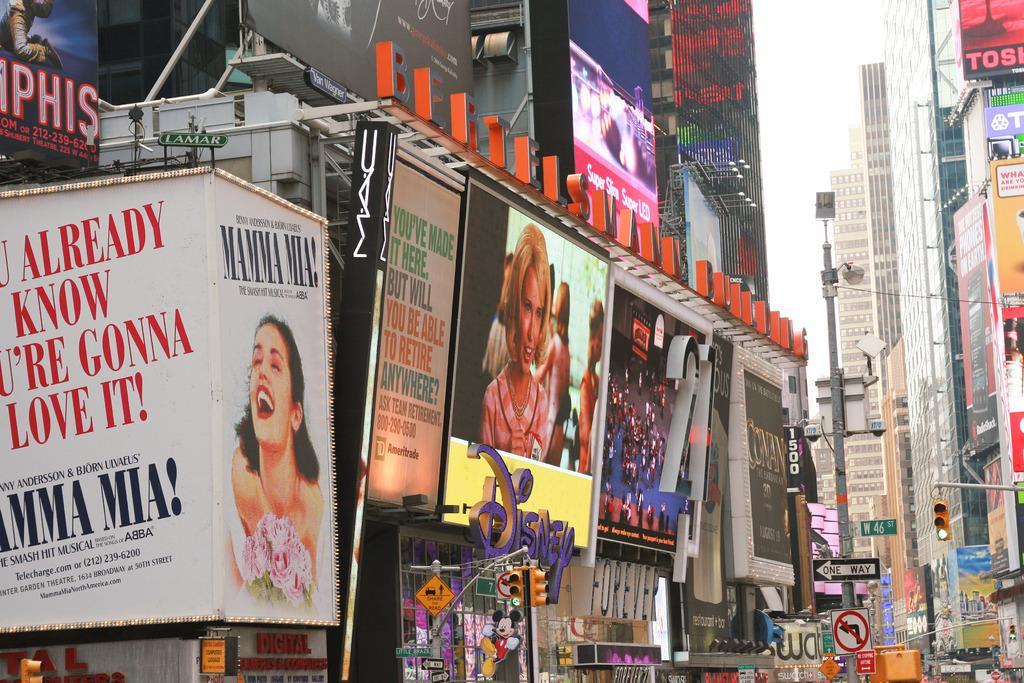Describe this image in one or two sentences. In this image we can see hoardings, traffic lights, buildings and some other objects. 